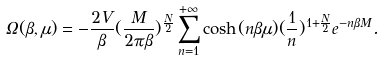<formula> <loc_0><loc_0><loc_500><loc_500>\Omega ( \beta , \mu ) = - \frac { 2 V } { \beta } ( \frac { M } { 2 \pi \beta } ) ^ { \frac { N } { 2 } } \sum _ { n = 1 } ^ { + \infty } \cosh ( n \beta \mu ) ( \frac { 1 } { n } ) ^ { 1 + \frac { N } { 2 } } e ^ { - n \beta M } .</formula> 